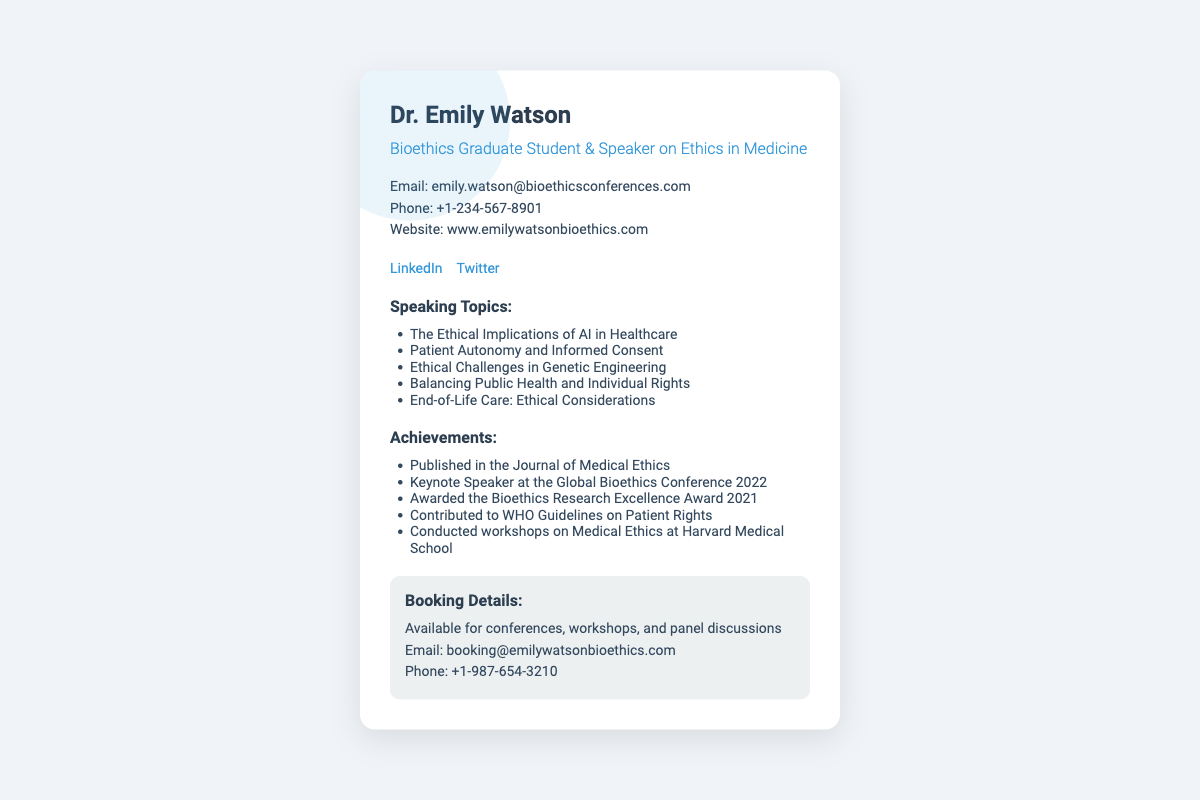What is the name of the speaker? The name of the speaker is prominently displayed at the top of the document.
Answer: Dr. Emily Watson What year was the Bioethics Research Excellence Award received? The year the award was received is listed in the achievements section of the document.
Answer: 2021 How many speaking topics are listed? The number of topics can be counted from the list provided under the speaking topics section.
Answer: 5 What is the website for booking inquiries? The website address is provided in the contact information section of the document.
Answer: www.emilywatsonbioethics.com What social media platform does the speaker use for professional networking? The social media section lists the platform used for professional networking.
Answer: LinkedIn What is the phone number for booking details? The phone number for booking inquiries is specified in the booking section of the document.
Answer: +1-987-654-3210 What type of events is Dr. Emily Watson available for? This information is found in the booking details section where events are mentioned.
Answer: Conferences, workshops, and panel discussions What award did Dr. Emily Watson receive in 2021? The relevant achievement is explicitly stated in the achievements section.
Answer: Bioethics Research Excellence Award What topic addresses ethical challenges in technology? The specific speaking topic related to technology is mentioned in the list of speaking topics.
Answer: The Ethical Implications of AI in Healthcare 